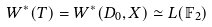<formula> <loc_0><loc_0><loc_500><loc_500>W ^ { * } ( T ) = W ^ { * } ( D _ { 0 } , X ) \simeq L ( \mathbb { F } _ { 2 } )</formula> 